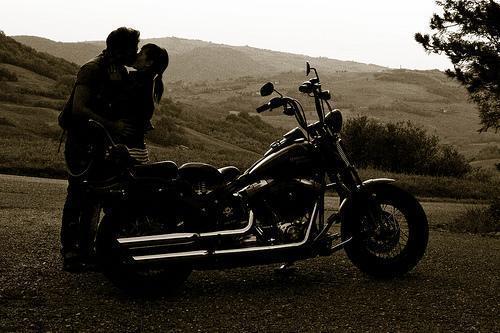How many people?
Give a very brief answer. 2. 